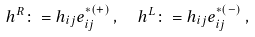Convert formula to latex. <formula><loc_0><loc_0><loc_500><loc_500>& h ^ { R } \colon = h _ { i j } e ^ { * ( + ) } _ { i j } \, , \quad h ^ { L } \colon = h _ { i j } e ^ { * ( - ) } _ { i j } \, ,</formula> 